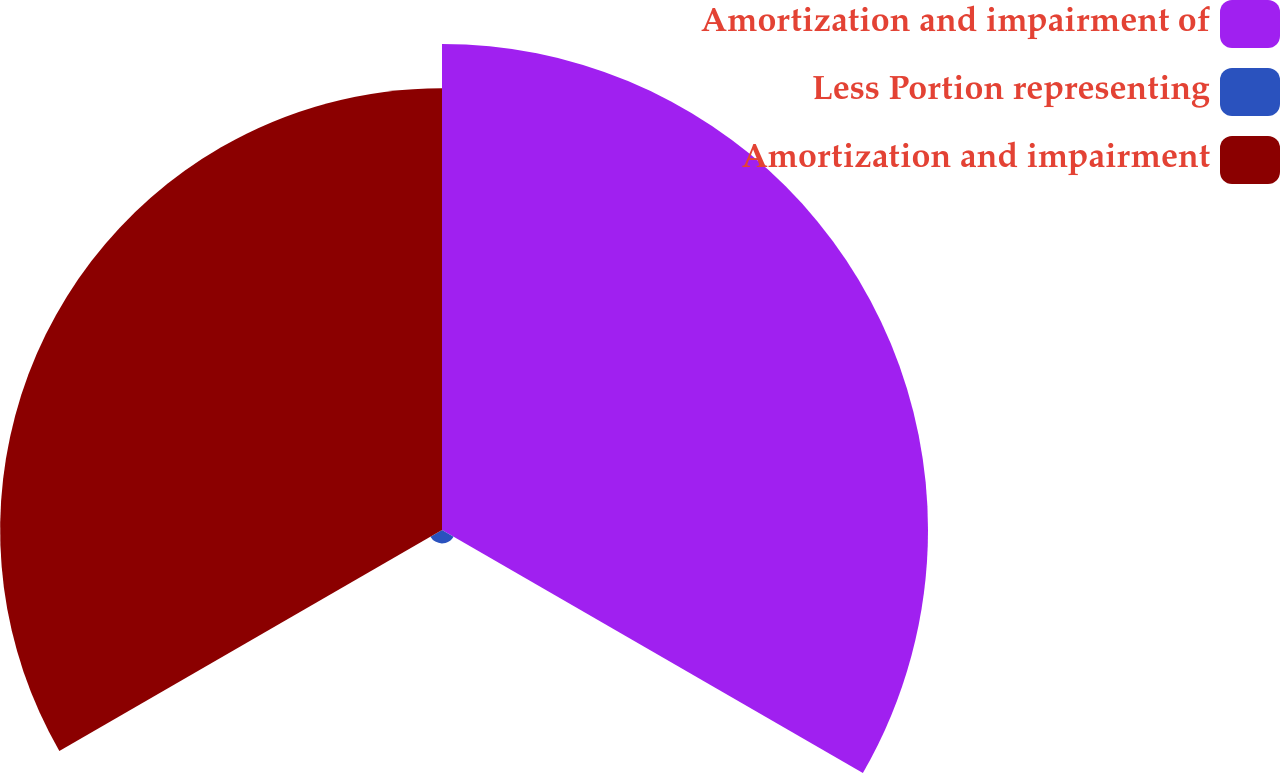Convert chart to OTSL. <chart><loc_0><loc_0><loc_500><loc_500><pie_chart><fcel>Amortization and impairment of<fcel>Less Portion representing<fcel>Amortization and impairment<nl><fcel>51.64%<fcel>1.42%<fcel>46.95%<nl></chart> 